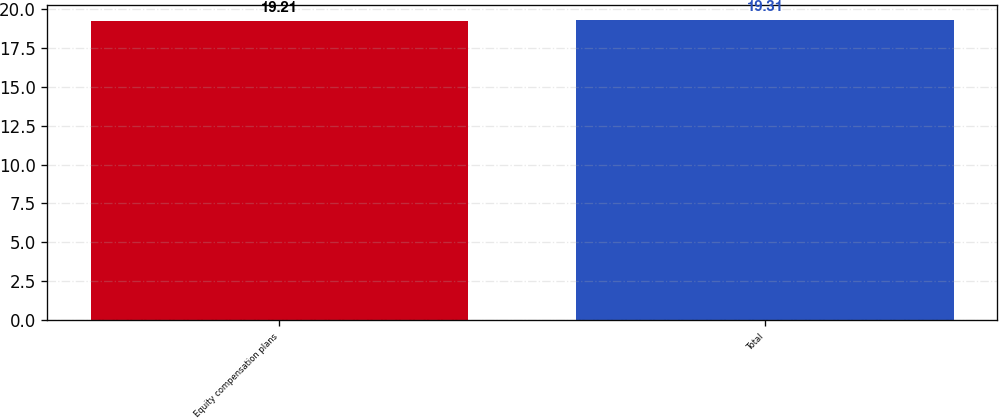Convert chart. <chart><loc_0><loc_0><loc_500><loc_500><bar_chart><fcel>Equity compensation plans<fcel>Total<nl><fcel>19.21<fcel>19.31<nl></chart> 